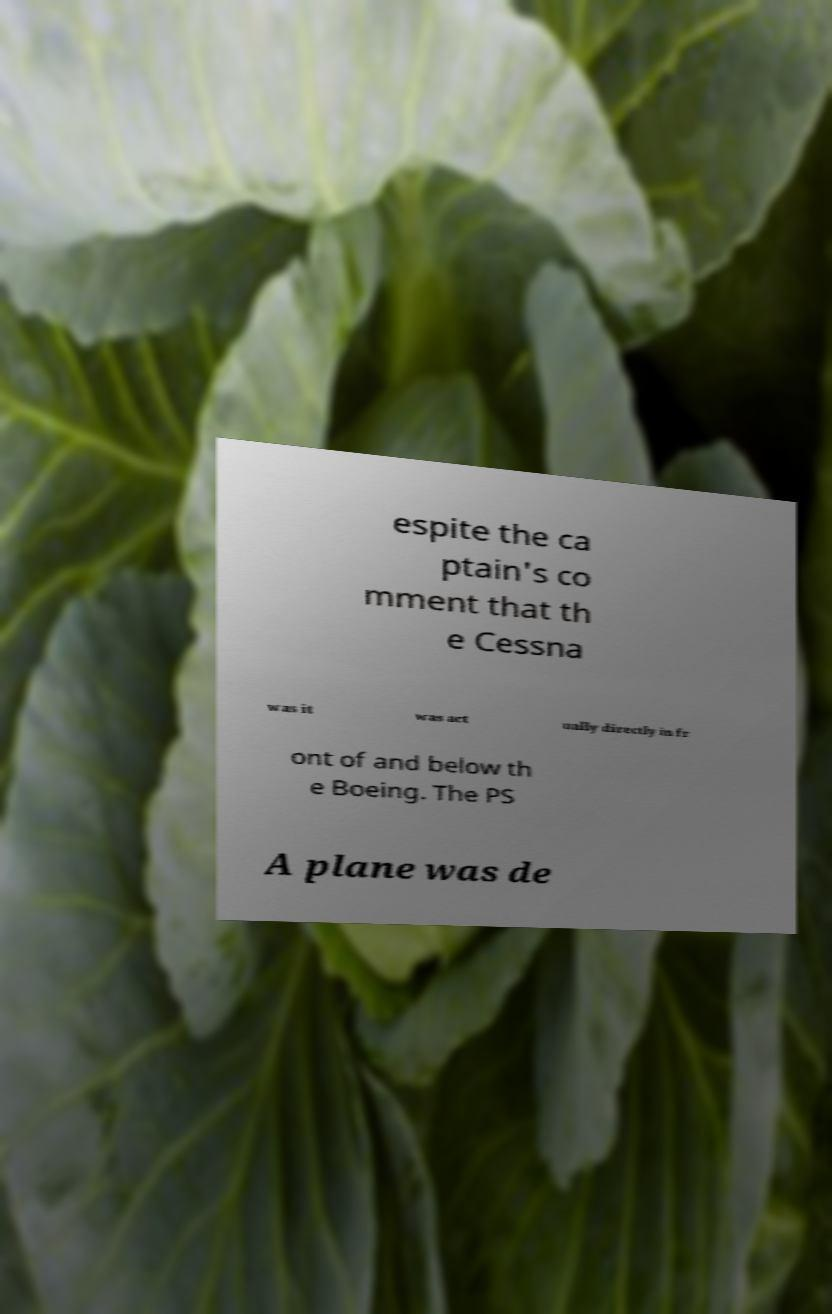Please identify and transcribe the text found in this image. espite the ca ptain's co mment that th e Cessna was it was act ually directly in fr ont of and below th e Boeing. The PS A plane was de 